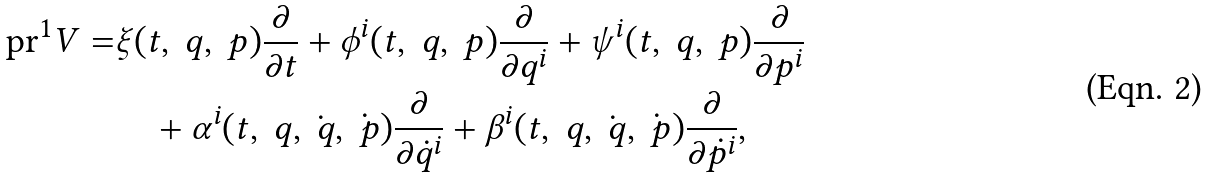Convert formula to latex. <formula><loc_0><loc_0><loc_500><loc_500>\text {pr} ^ { 1 } V = & \xi ( t , \ q , \ p ) \frac { \partial } { \partial t } + \phi ^ { i } ( t , \ q , \ p ) \frac { \partial } { \partial q ^ { i } } + \psi ^ { i } ( t , \ q , \ p ) \frac { \partial } { \partial p ^ { i } } \\ & \quad + \alpha ^ { i } ( t , \ q , \dot { \ q } , \dot { \ p } ) \frac { \partial } { \partial \dot { q } ^ { i } } + \beta ^ { i } ( t , \ q , \dot { \ q } , \dot { \ p } ) \frac { \partial } { \partial \dot { p } ^ { i } } ,</formula> 